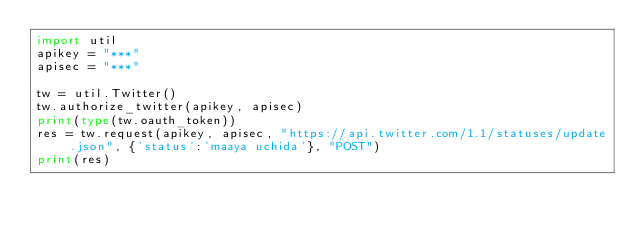Convert code to text. <code><loc_0><loc_0><loc_500><loc_500><_Python_>import util
apikey = "***"
apisec = "***"

tw = util.Twitter()
tw.authorize_twitter(apikey, apisec)
print(type(tw.oauth_token))
res = tw.request(apikey, apisec, "https://api.twitter.com/1.1/statuses/update.json", {'status':'maaya uchida'}, "POST")
print(res)
</code> 